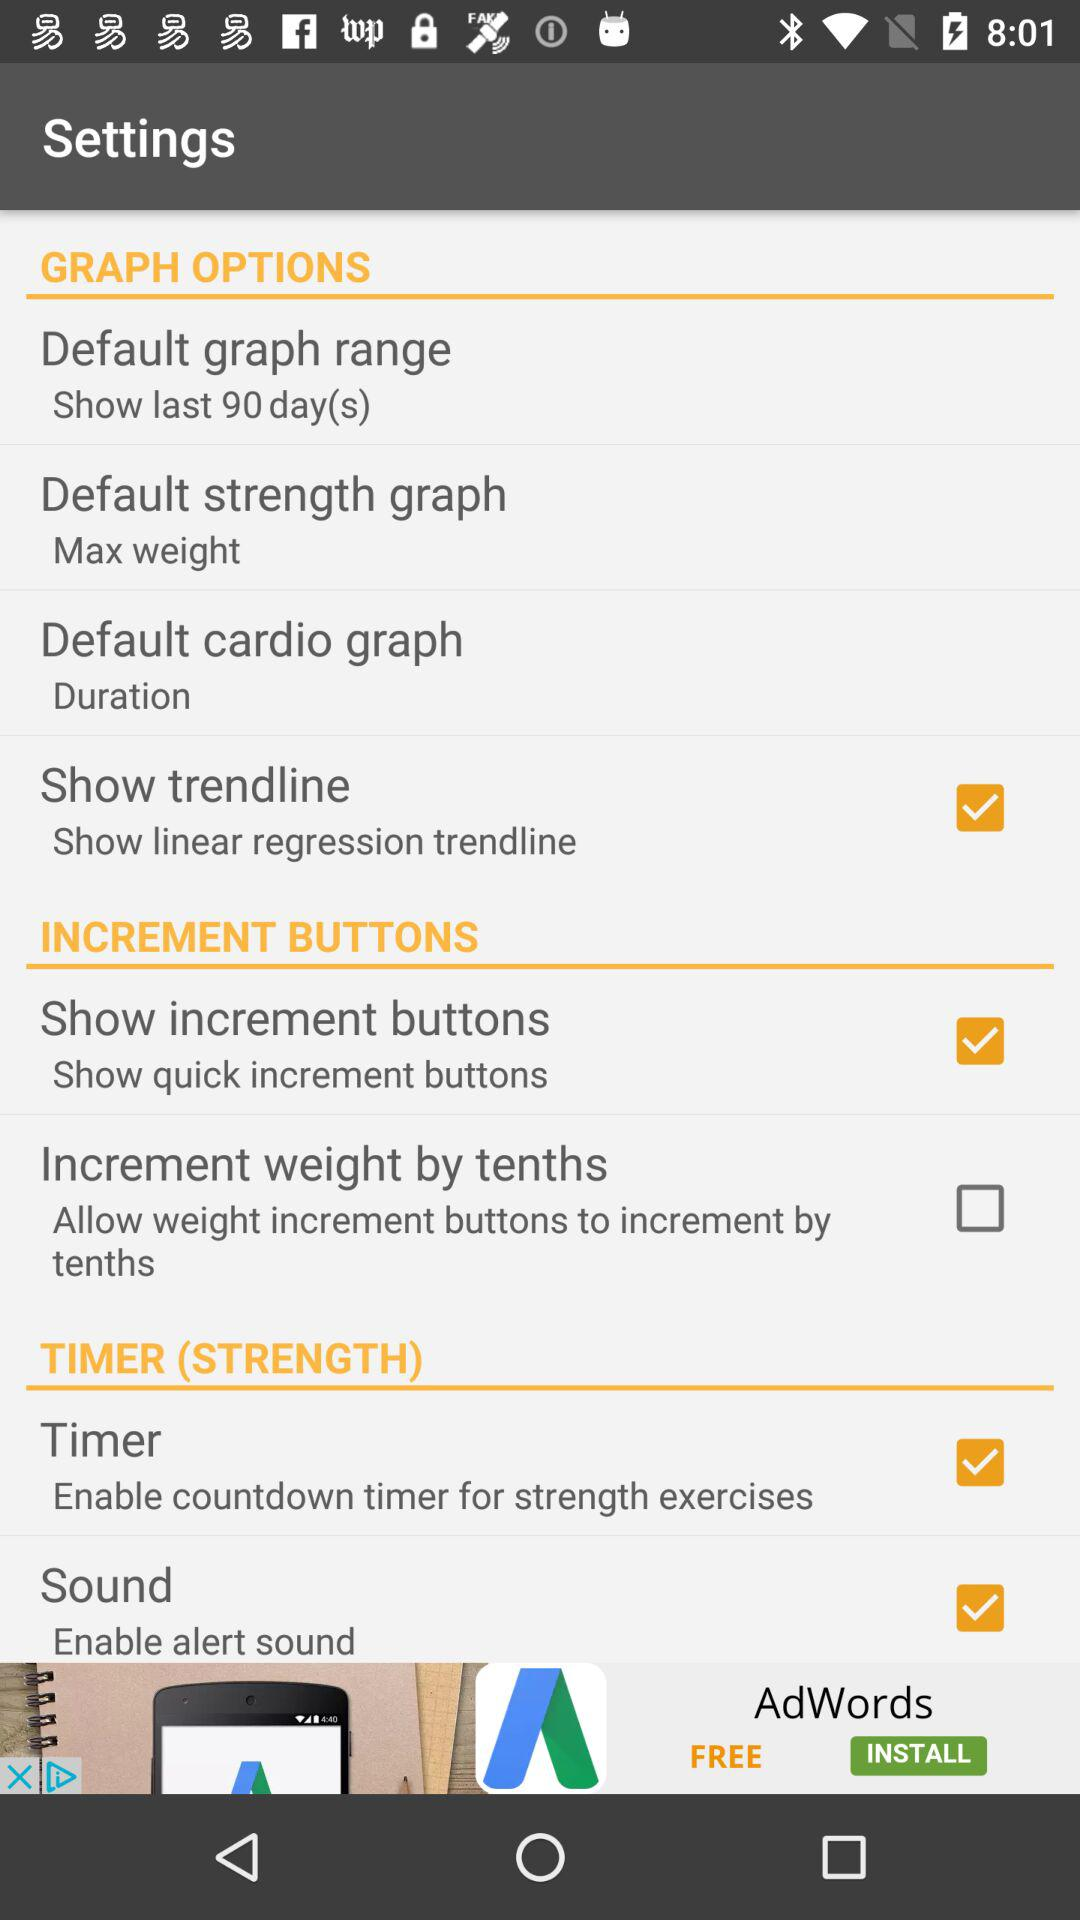How many checkbox items are there in the 'Timer (Strength)' section?
Answer the question using a single word or phrase. 2 